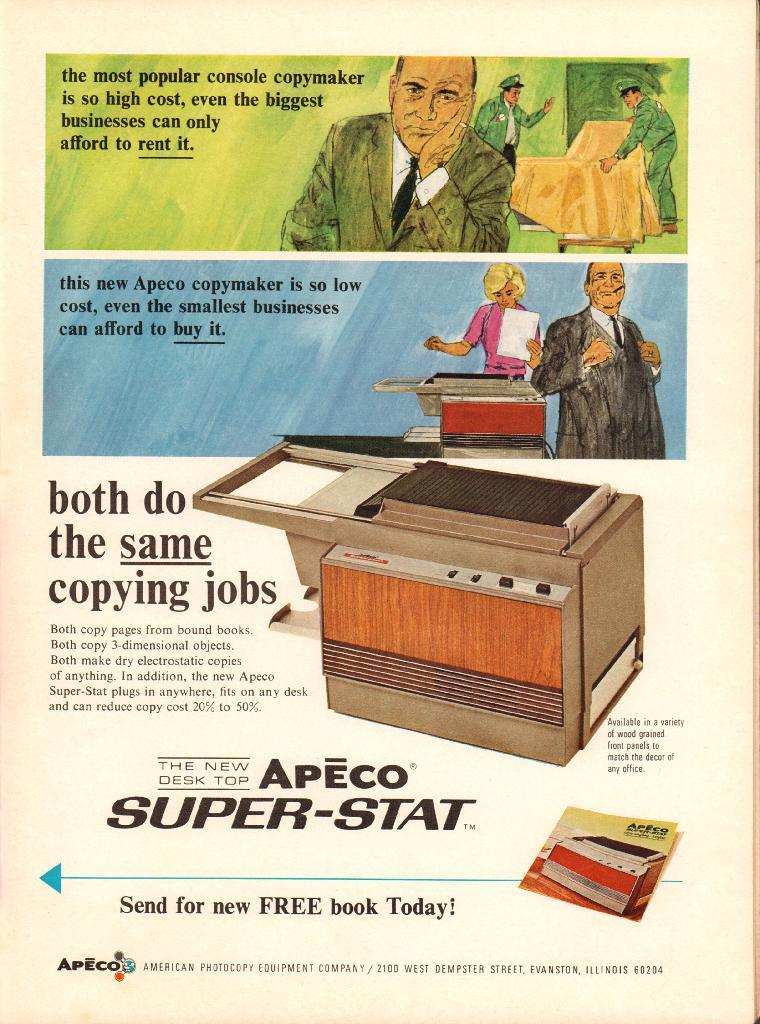Provide a one-sentence caption for the provided image. Ad old fashioned ad promotes the sale of Apeco copymakers. 